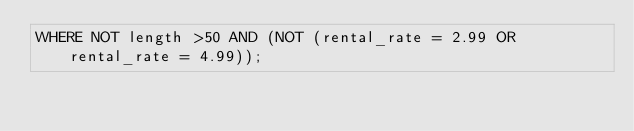<code> <loc_0><loc_0><loc_500><loc_500><_SQL_>WHERE NOT length >50 AND (NOT (rental_rate = 2.99 OR rental_rate = 4.99));
</code> 